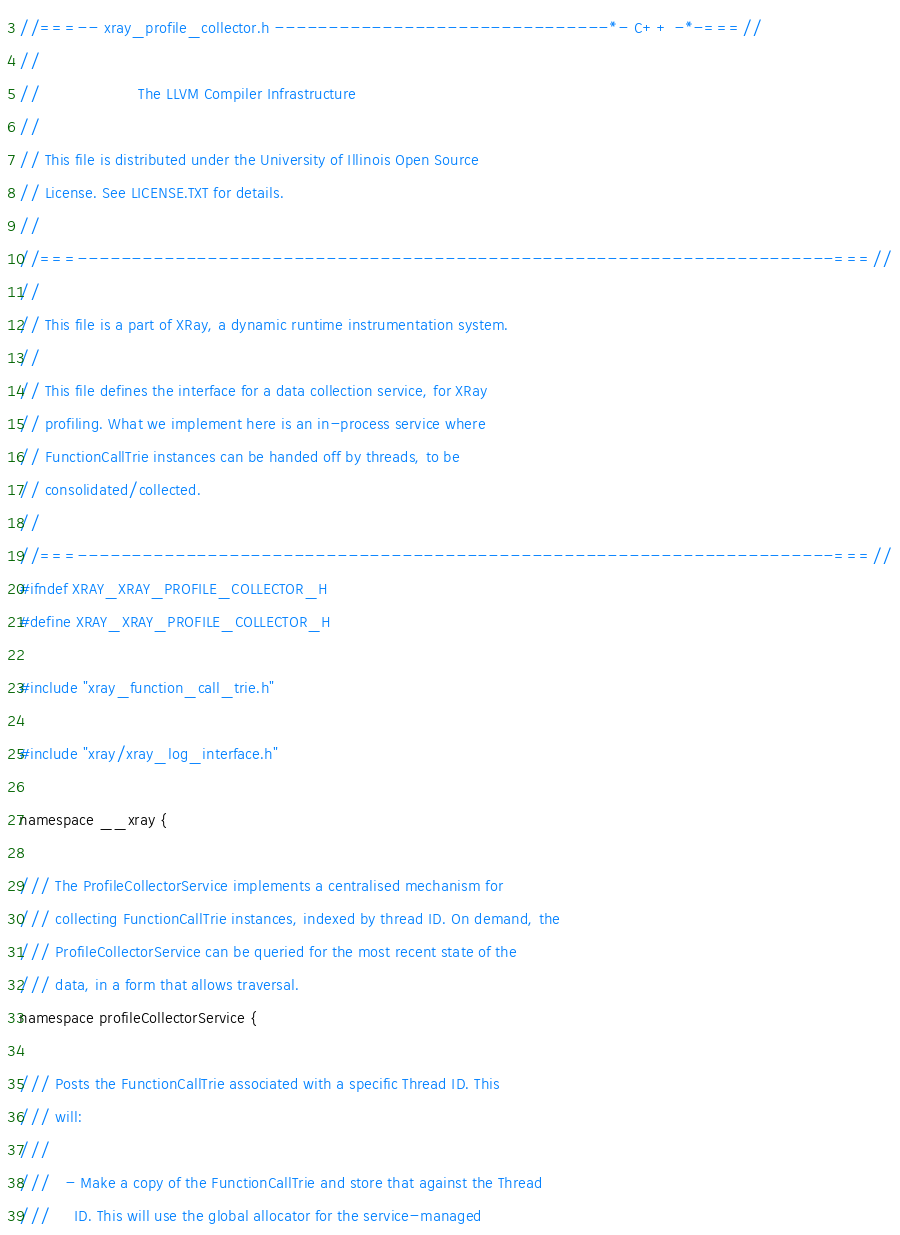Convert code to text. <code><loc_0><loc_0><loc_500><loc_500><_C_>//===-- xray_profile_collector.h -------------------------------*- C++ -*-===//
//
//                     The LLVM Compiler Infrastructure
//
// This file is distributed under the University of Illinois Open Source
// License. See LICENSE.TXT for details.
//
//===----------------------------------------------------------------------===//
//
// This file is a part of XRay, a dynamic runtime instrumentation system.
//
// This file defines the interface for a data collection service, for XRay
// profiling. What we implement here is an in-process service where
// FunctionCallTrie instances can be handed off by threads, to be
// consolidated/collected.
//
//===----------------------------------------------------------------------===//
#ifndef XRAY_XRAY_PROFILE_COLLECTOR_H
#define XRAY_XRAY_PROFILE_COLLECTOR_H

#include "xray_function_call_trie.h"

#include "xray/xray_log_interface.h"

namespace __xray {

/// The ProfileCollectorService implements a centralised mechanism for
/// collecting FunctionCallTrie instances, indexed by thread ID. On demand, the
/// ProfileCollectorService can be queried for the most recent state of the
/// data, in a form that allows traversal.
namespace profileCollectorService {

/// Posts the FunctionCallTrie associated with a specific Thread ID. This
/// will:
///
///   - Make a copy of the FunctionCallTrie and store that against the Thread
///     ID. This will use the global allocator for the service-managed</code> 